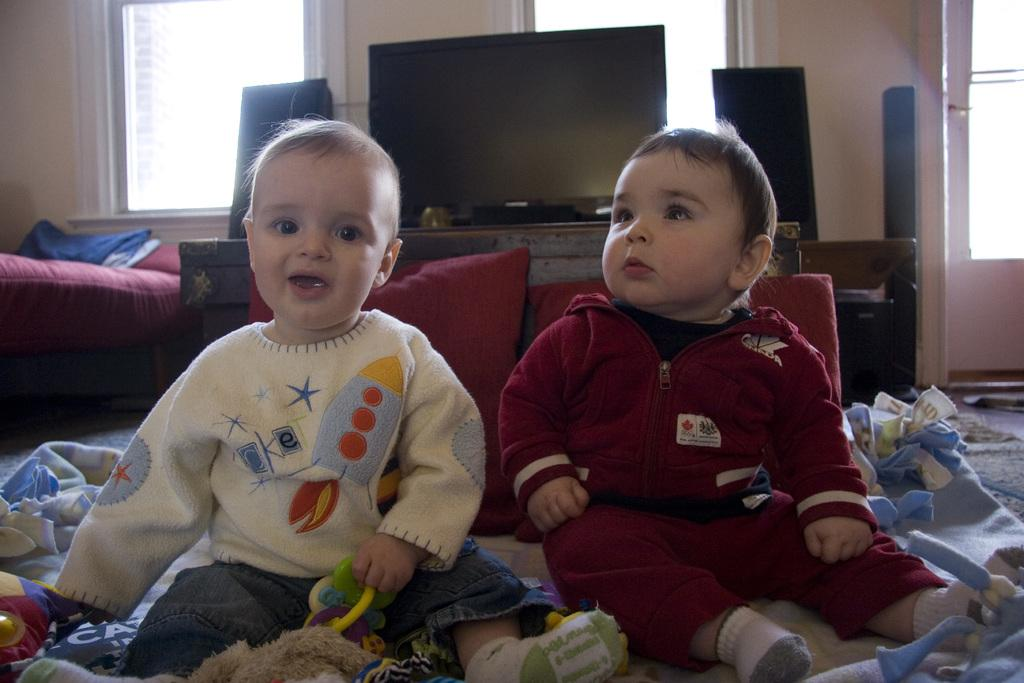How many children are present in the image? There are two children in the middle of the image. What can be seen in the background of the image? There is a television in the background of the image. What objects are on either side of the image? There are speakers on either side of the image. What is located on the left side of the image? There is a bed on the left side of the image. What is the weight of the van parked next to the bed in the image? There is no van present in the image; it only features two children, a television, speakers, and a bed. 